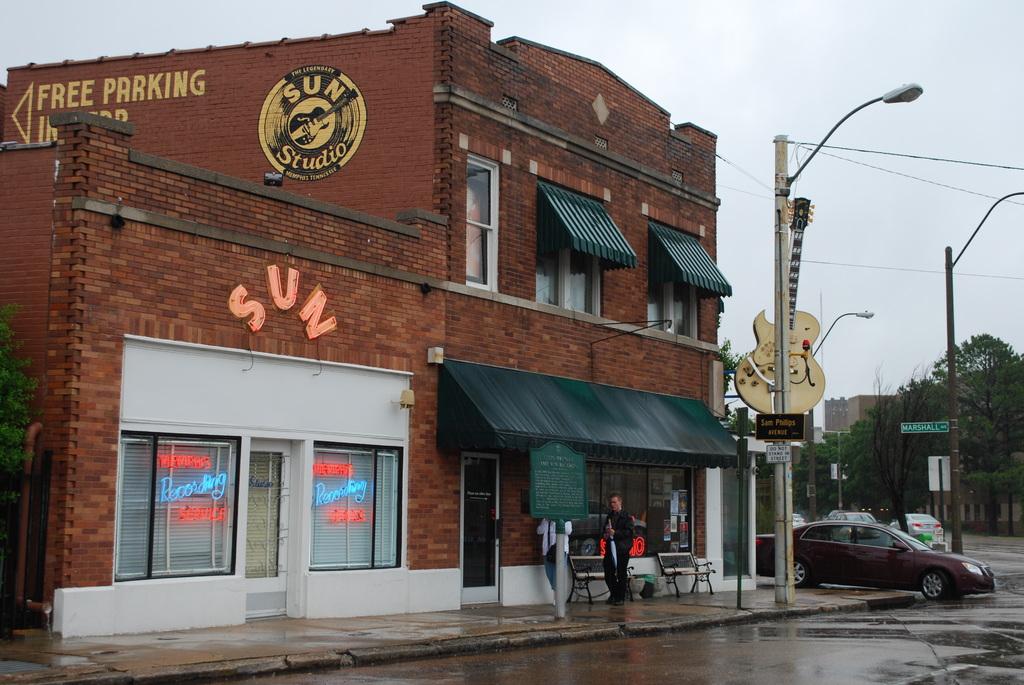What is that store with the neon lights called?
Ensure brevity in your answer.  Sun. What is free?
Provide a short and direct response. Parking. 